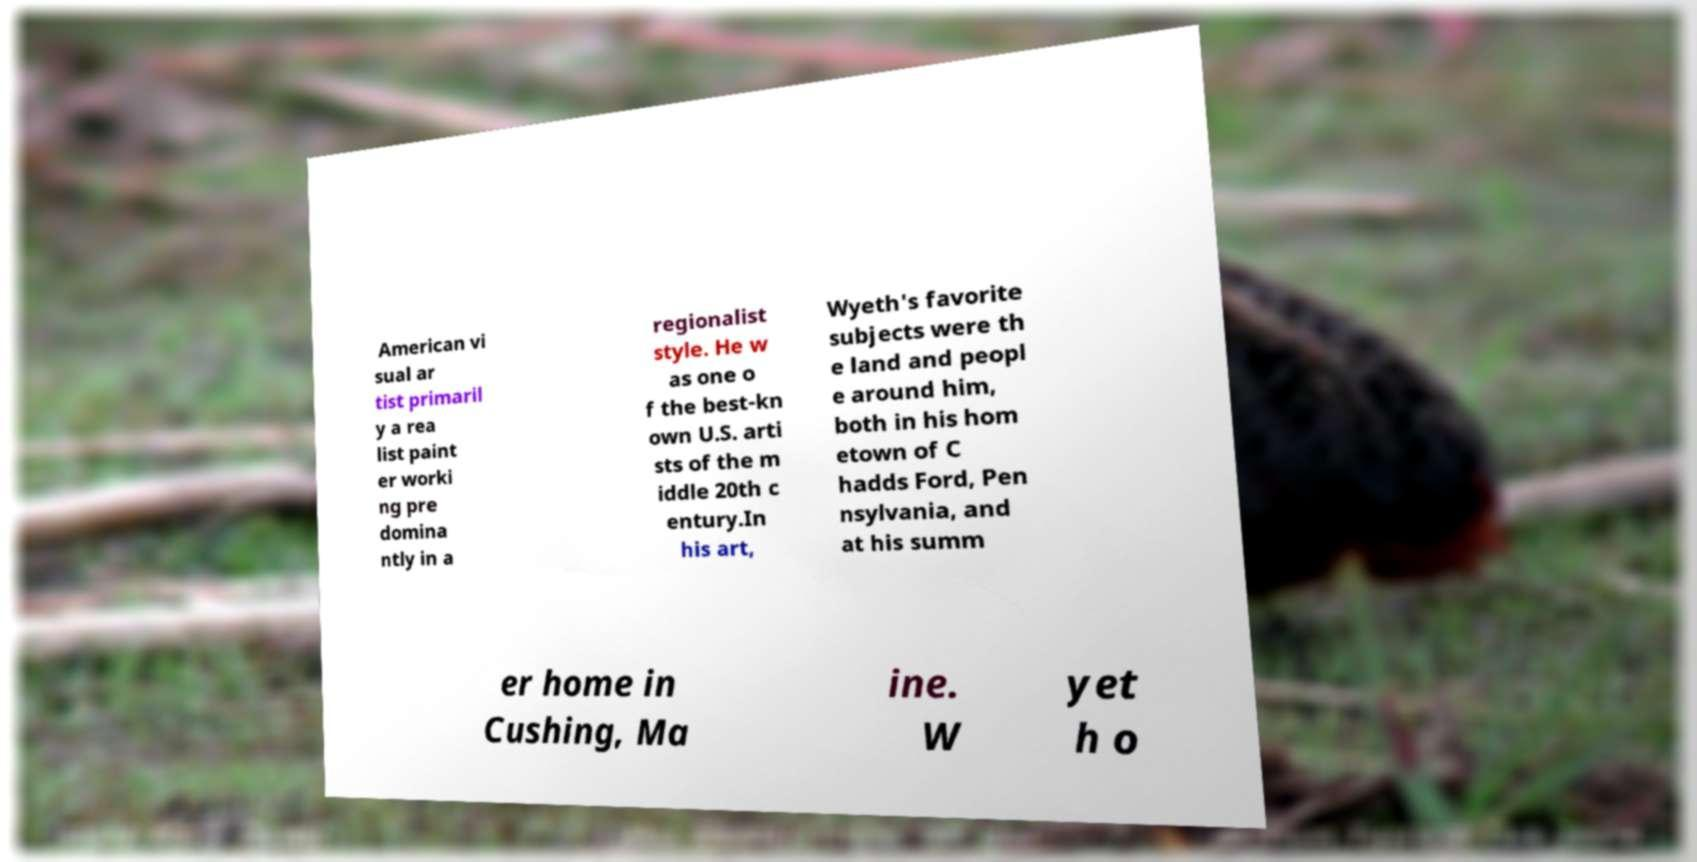Can you accurately transcribe the text from the provided image for me? American vi sual ar tist primaril y a rea list paint er worki ng pre domina ntly in a regionalist style. He w as one o f the best-kn own U.S. arti sts of the m iddle 20th c entury.In his art, Wyeth's favorite subjects were th e land and peopl e around him, both in his hom etown of C hadds Ford, Pen nsylvania, and at his summ er home in Cushing, Ma ine. W yet h o 